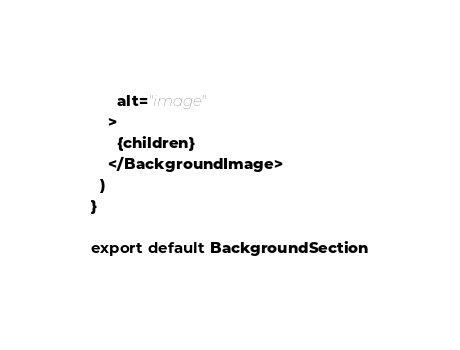Convert code to text. <code><loc_0><loc_0><loc_500><loc_500><_JavaScript_>      alt="image"
    >
      {children}
    </BackgroundImage>
  )
}

export default BackgroundSection
</code> 